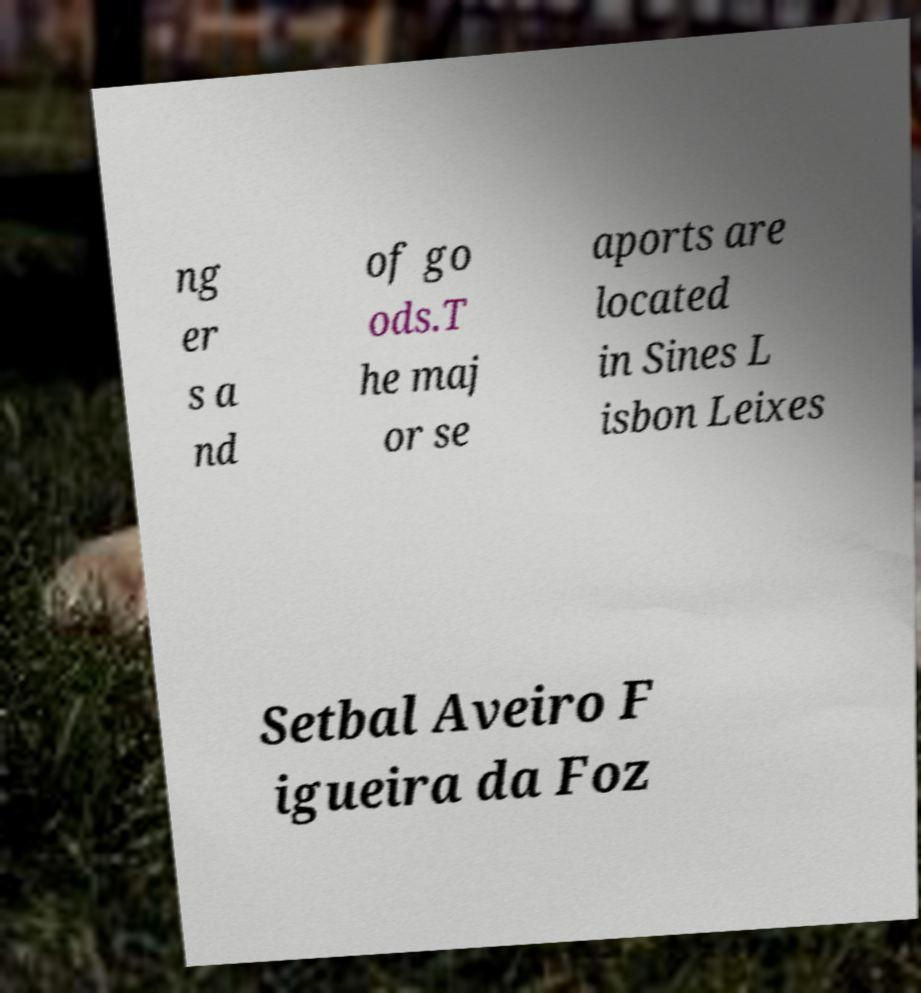Could you assist in decoding the text presented in this image and type it out clearly? ng er s a nd of go ods.T he maj or se aports are located in Sines L isbon Leixes Setbal Aveiro F igueira da Foz 